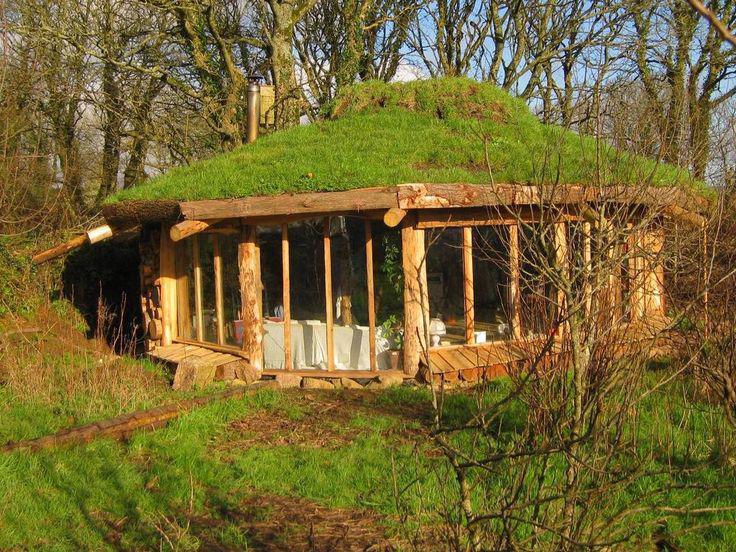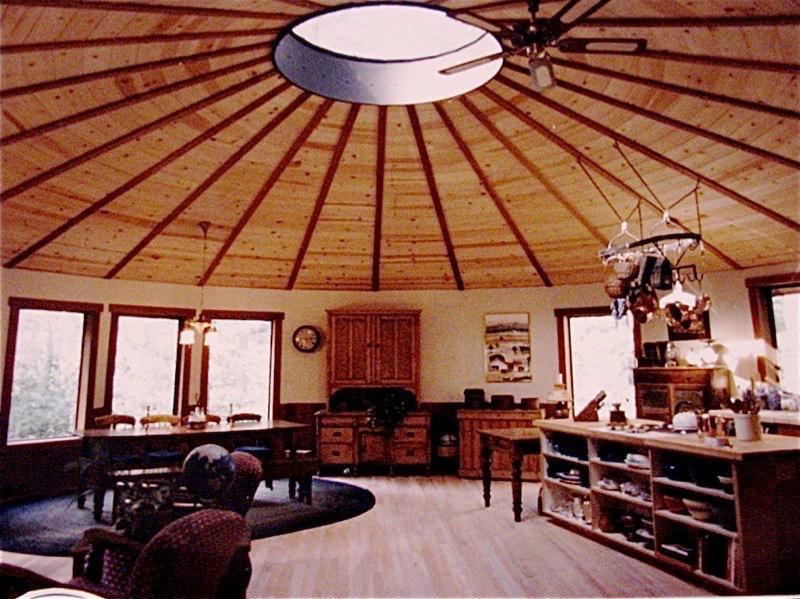The first image is the image on the left, the second image is the image on the right. Assess this claim about the two images: "At least one house has no visible windows.". Correct or not? Answer yes or no. No. 